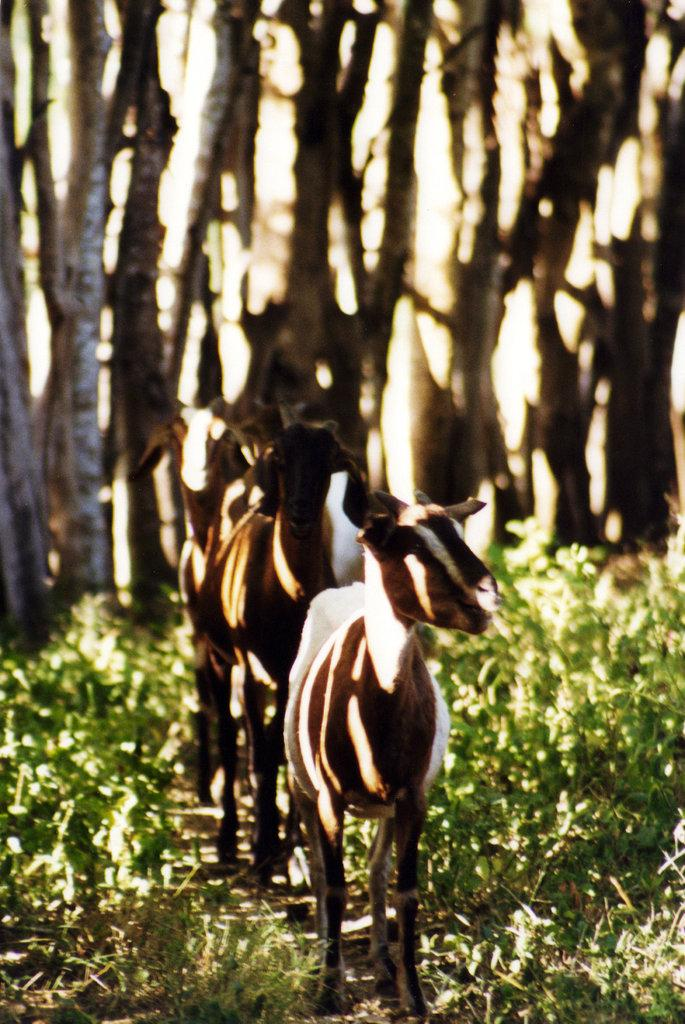What types of living organisms can be seen in the image? There are animals in the image. Where are the animals located in relation to the plants? The animals are in between plants. What can be seen in the background of the image? There are stems visible in the background of the image. What type of slope can be seen in the image? There is no slope present in the image; it features animals in between plants and stems in the background. How many people are in the crowd in the image? There is no crowd present in the image. 